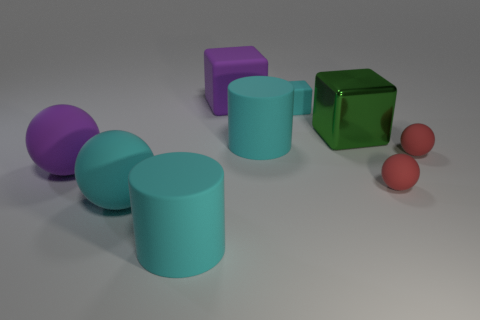Describe the lighting in the scene. How does it affect the appearance of the objects? The scene has a soft, diffused lighting that minimizes harsh shadows and evenly illuminates the objects. This type of lighting brings out the subtle textures of the objects and provides clarity to their colors. 